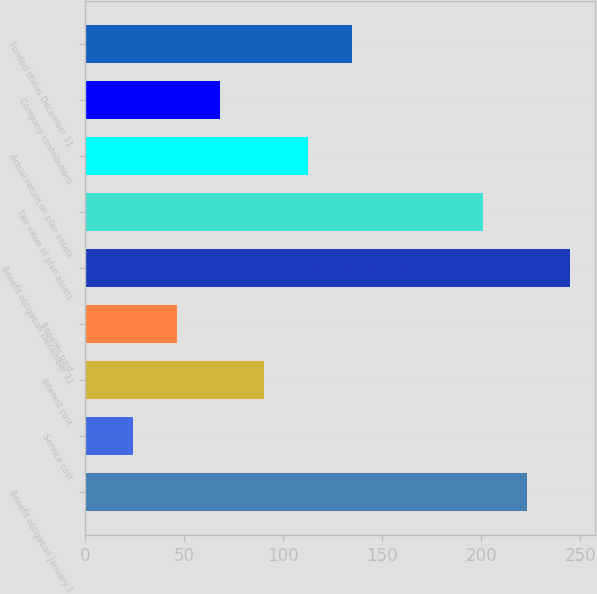<chart> <loc_0><loc_0><loc_500><loc_500><bar_chart><fcel>Benefit obligation January 1<fcel>Service cost<fcel>Interest cost<fcel>Benefits paid<fcel>Benefit obligation December 31<fcel>Fair value of plan assets<fcel>Actual return on plan assets<fcel>Company contributions<fcel>Funded status December 31<nl><fcel>223<fcel>24.1<fcel>90.4<fcel>46.2<fcel>245.1<fcel>200.9<fcel>112.5<fcel>68.3<fcel>134.6<nl></chart> 